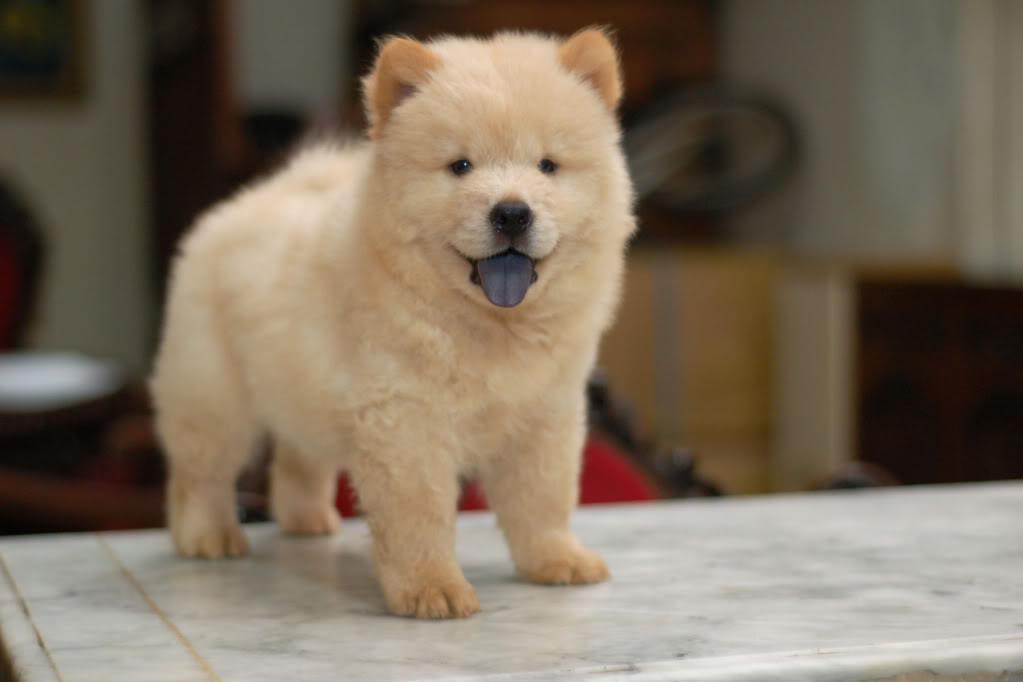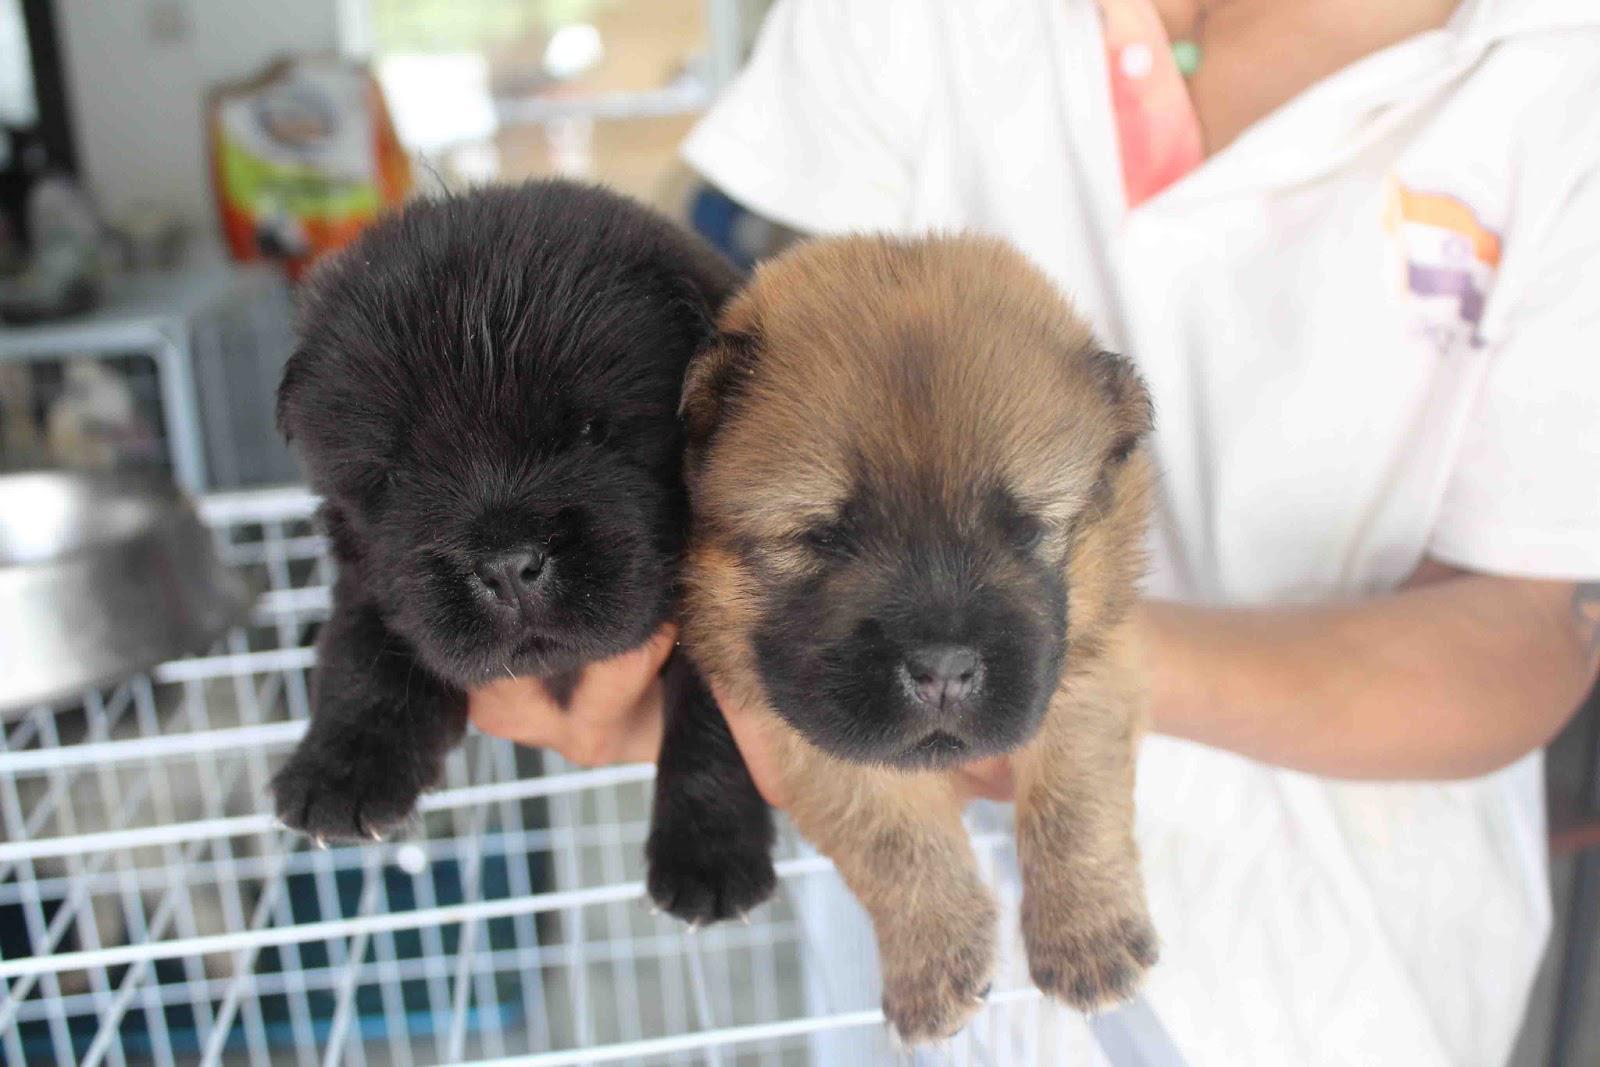The first image is the image on the left, the second image is the image on the right. Analyze the images presented: Is the assertion "One of the images shows a fluffy puppy running over grass toward the camera." valid? Answer yes or no. No. The first image is the image on the left, the second image is the image on the right. Assess this claim about the two images: "a puppy is leaping in the grass". Correct or not? Answer yes or no. No. 